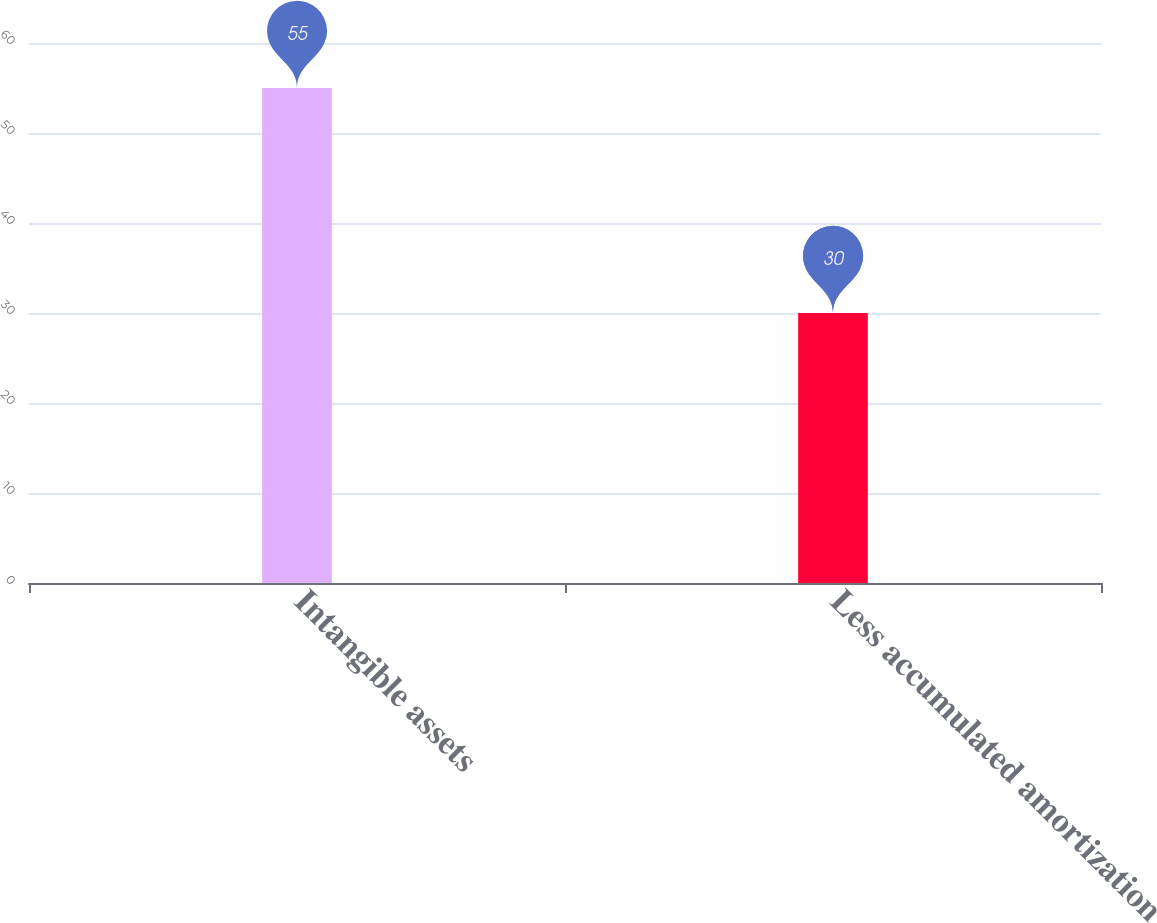Convert chart to OTSL. <chart><loc_0><loc_0><loc_500><loc_500><bar_chart><fcel>Intangible assets<fcel>Less accumulated amortization<nl><fcel>55<fcel>30<nl></chart> 